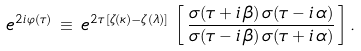<formula> <loc_0><loc_0><loc_500><loc_500>e ^ { 2 i \, \varphi ( \tau ) } \, \equiv \, e ^ { 2 \tau \, [ \zeta ( \kappa ) - \zeta ( \lambda ) ] } \, \left [ \, \frac { \sigma ( \tau + i \, \beta ) \, \sigma ( \tau - i \, \alpha ) } { \sigma ( \tau - i \, \beta ) \, \sigma ( \tau + i \, \alpha ) } \, \right ] .</formula> 